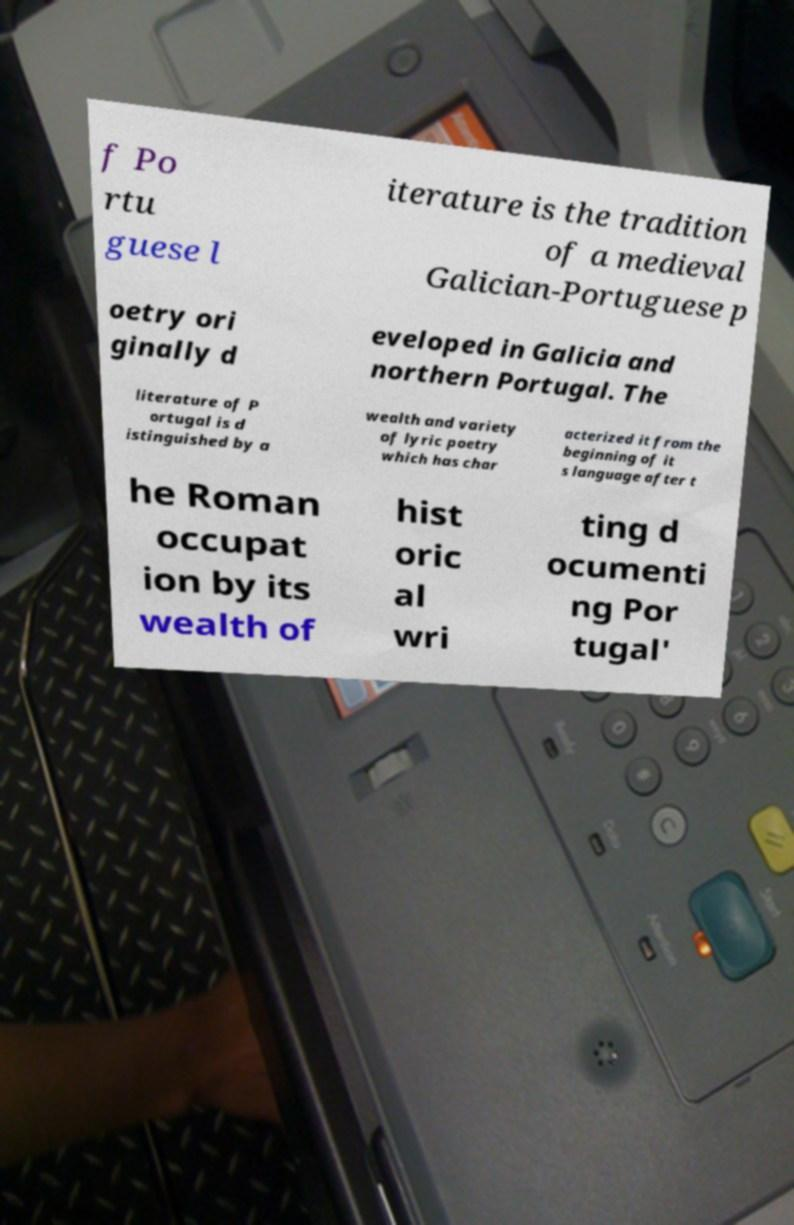Can you accurately transcribe the text from the provided image for me? f Po rtu guese l iterature is the tradition of a medieval Galician-Portuguese p oetry ori ginally d eveloped in Galicia and northern Portugal. The literature of P ortugal is d istinguished by a wealth and variety of lyric poetry which has char acterized it from the beginning of it s language after t he Roman occupat ion by its wealth of hist oric al wri ting d ocumenti ng Por tugal' 